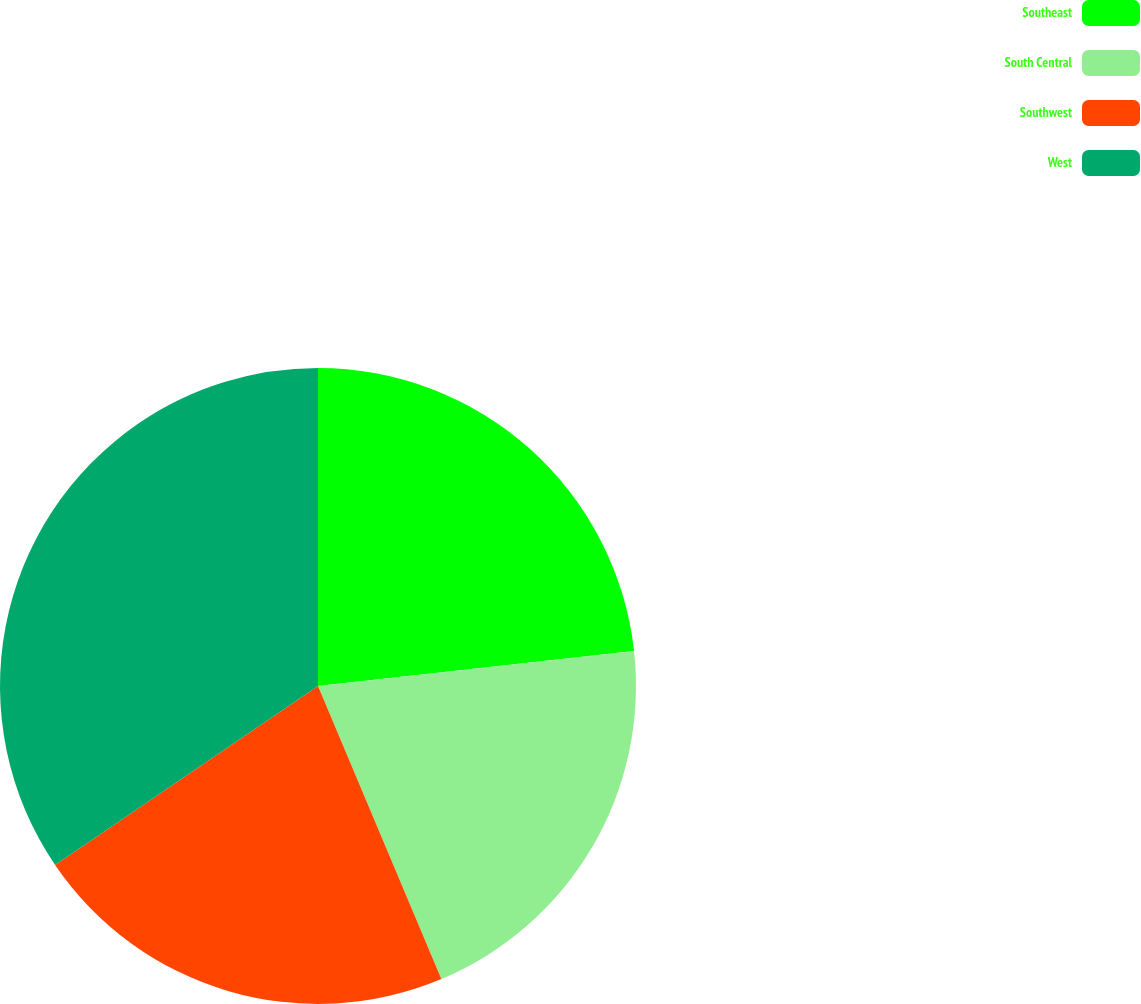Convert chart. <chart><loc_0><loc_0><loc_500><loc_500><pie_chart><fcel>Southeast<fcel>South Central<fcel>Southwest<fcel>West<nl><fcel>23.24%<fcel>20.42%<fcel>21.83%<fcel>34.51%<nl></chart> 